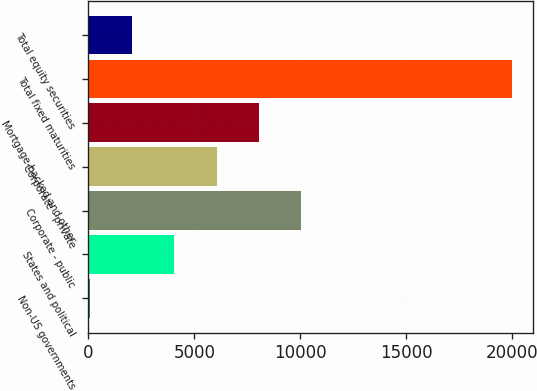Convert chart to OTSL. <chart><loc_0><loc_0><loc_500><loc_500><bar_chart><fcel>Non-US governments<fcel>States and political<fcel>Corporate - public<fcel>Corporate - private<fcel>Mortgage-backed and other<fcel>Total fixed maturities<fcel>Total equity securities<nl><fcel>75.1<fcel>4058.16<fcel>10032.8<fcel>6049.69<fcel>8041.22<fcel>19990.4<fcel>2066.63<nl></chart> 